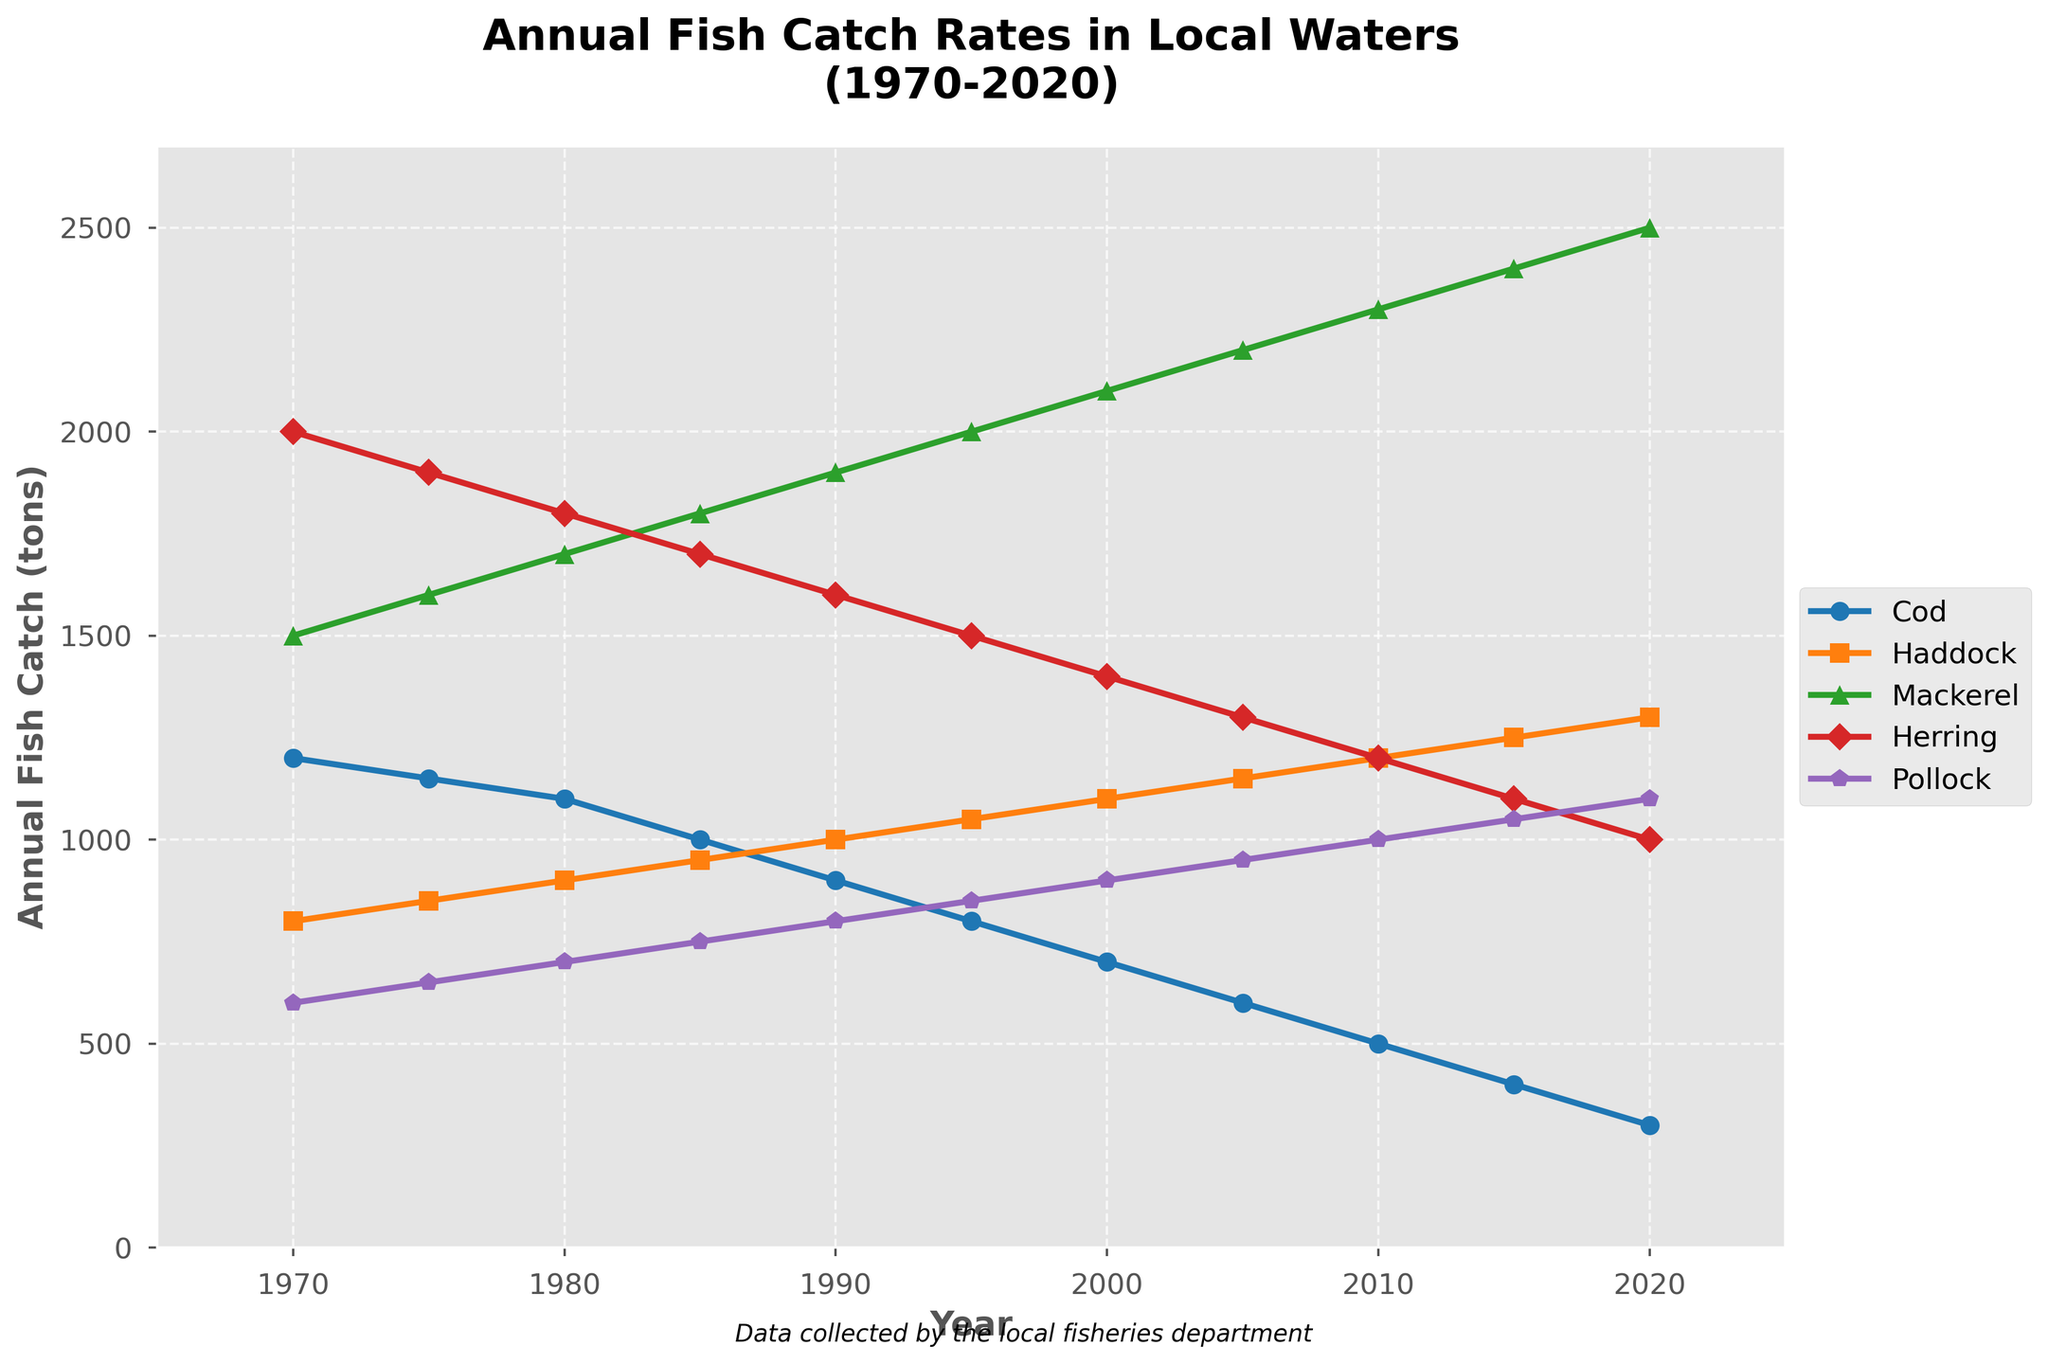What is the trend of the Cod catch rates from 1970 to 2020? The catch rates for Cod show a steady decline from 1200 tons in 1970 to 300 tons in 2020, indicating a continuous downward trend over the 50-year period.
Answer: Steady decline Which species had the highest catch rate in 2020? In 2020, the Mackerel had the highest catch rate at 2500 tons, which is visibly the tallest line among the species.
Answer: Mackerel How many tons of Herring were caught in 1990 compared to 1970? The catch rate for Herring was 2000 tons in 1970 and decreased to 1600 tons in 1990, indicating a 400-ton decrease.
Answer: 1600 tons, 400 tons less Between which consecutive years did the Haddock catch rates increase the most significantly? The most significant increase in Haddock catch rates occurred between 2015 and 2020, where the rate increased from 1250 tons to 1300 tons, a difference of 50 tons.
Answer: Between 2015 and 2020 What is the average catch rate for Pollock from 1970 to 2020? To find the average catch rate, sum all the yearly catch rates for Pollock (600+650+700+750+800+850+900+950+1000+1050+1100) which equals 9350 tons, then divide by the number of years (11). So, the average is 9350 / 11 ≈ 850 tons.
Answer: 850 tons Compare the trends of Mackerel and Herring catch rates from 1970 to 2020. Mackerel catch rates show a consistent rise from 1500 tons in 1970 to 2500 tons in 2020, while Herring catch rates display a decreasing trend from 2000 tons in 1970 to 1000 tons in 2020.
Answer: Mackerel increases, Herring decreases Did any species maintain a relatively stable catch rate over the 50 years? The Haddock catch rates show the least variability, increasing gradually from 800 tons in 1970 to 1300 tons in 2020.
Answer: Haddock Which year did the Mackerel catch rate surpass 2000 tons? The Mackerel catch rate surpassed 2000 tons in the year 2000.
Answer: 2000 Was there any species with consistently increasing catch rates over the years? Mackerel shows a consistent increase in catch rates every year from 1970 to 2020.
Answer: Mackerel What's the combined total of Cod and Pollock catch rates in 1985? Sum the catch rates for Cod (1000 tons) and Pollock (750 tons) in 1985, which equals 1750 tons.
Answer: 1750 tons 